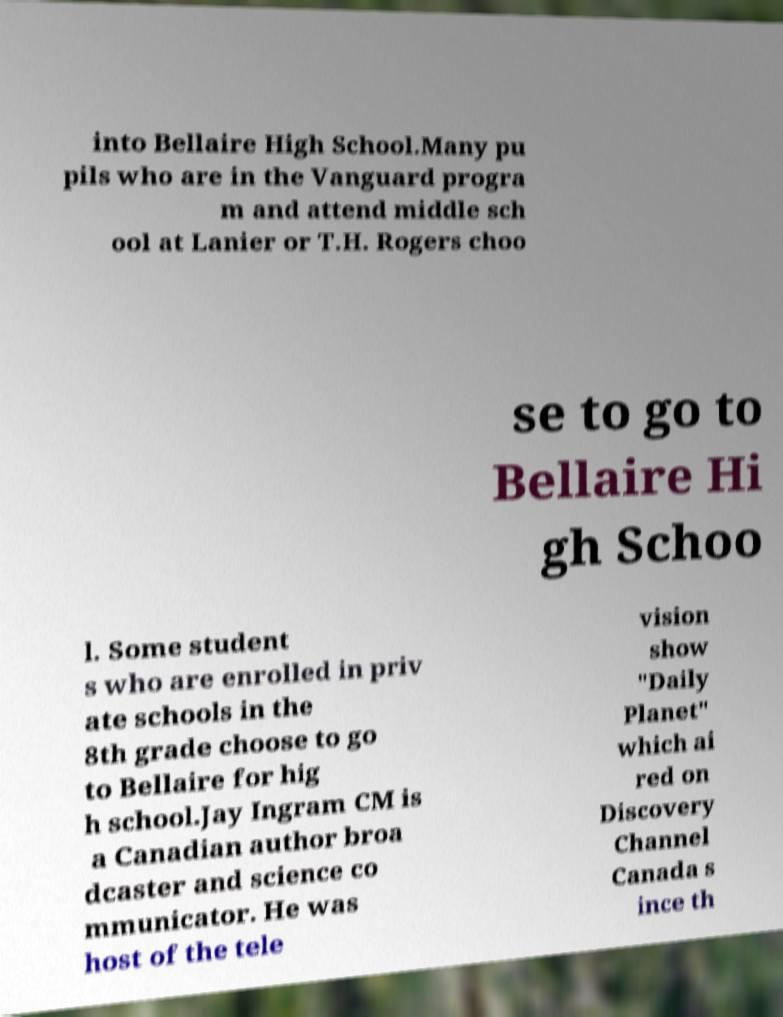Could you assist in decoding the text presented in this image and type it out clearly? into Bellaire High School.Many pu pils who are in the Vanguard progra m and attend middle sch ool at Lanier or T.H. Rogers choo se to go to Bellaire Hi gh Schoo l. Some student s who are enrolled in priv ate schools in the 8th grade choose to go to Bellaire for hig h school.Jay Ingram CM is a Canadian author broa dcaster and science co mmunicator. He was host of the tele vision show "Daily Planet" which ai red on Discovery Channel Canada s ince th 